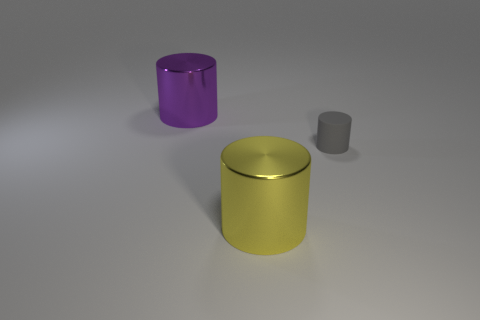Are there any other things that are the same size as the matte cylinder?
Your answer should be compact. No. How many big shiny cylinders are on the right side of the big purple cylinder and behind the yellow shiny object?
Offer a terse response. 0. How many balls are either yellow objects or large purple objects?
Your answer should be compact. 0. Are there any purple objects?
Your response must be concise. Yes. What number of other things are there of the same material as the big purple cylinder
Your response must be concise. 1. There is a thing that is the same size as the yellow metallic cylinder; what material is it?
Ensure brevity in your answer.  Metal. There is a large metallic object right of the purple thing; does it have the same shape as the gray thing?
Your answer should be very brief. Yes. What number of things are things that are to the left of the large yellow cylinder or gray things?
Your answer should be very brief. 2. What shape is the metallic object that is the same size as the yellow metal cylinder?
Your answer should be compact. Cylinder. Is the size of the metal cylinder in front of the big purple object the same as the shiny object that is behind the large yellow object?
Offer a terse response. Yes. 